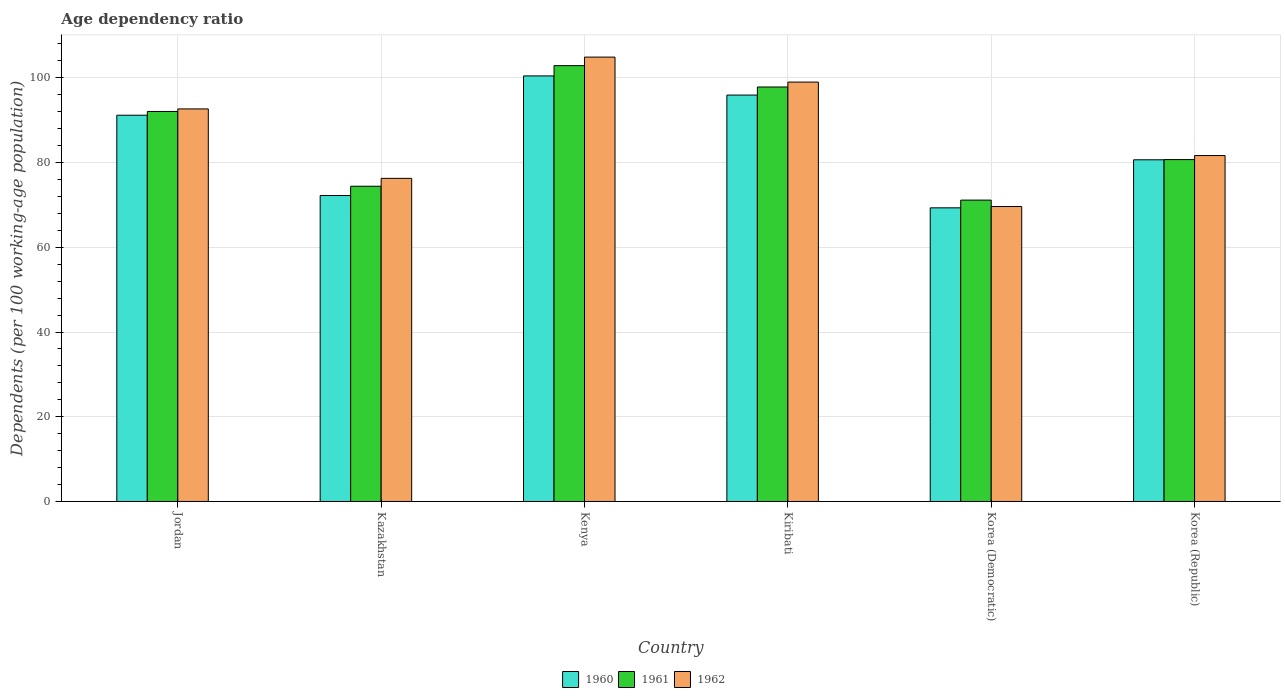How many different coloured bars are there?
Provide a succinct answer. 3. Are the number of bars per tick equal to the number of legend labels?
Your answer should be compact. Yes. How many bars are there on the 3rd tick from the left?
Your answer should be very brief. 3. How many bars are there on the 4th tick from the right?
Your response must be concise. 3. What is the label of the 2nd group of bars from the left?
Provide a short and direct response. Kazakhstan. What is the age dependency ratio in in 1961 in Korea (Republic)?
Offer a terse response. 80.71. Across all countries, what is the maximum age dependency ratio in in 1962?
Your response must be concise. 104.91. Across all countries, what is the minimum age dependency ratio in in 1960?
Your answer should be compact. 69.32. In which country was the age dependency ratio in in 1960 maximum?
Offer a very short reply. Kenya. In which country was the age dependency ratio in in 1962 minimum?
Ensure brevity in your answer.  Korea (Democratic). What is the total age dependency ratio in in 1962 in the graph?
Provide a short and direct response. 524.17. What is the difference between the age dependency ratio in in 1961 in Kiribati and that in Korea (Republic)?
Offer a very short reply. 17.14. What is the difference between the age dependency ratio in in 1960 in Kazakhstan and the age dependency ratio in in 1962 in Korea (Democratic)?
Give a very brief answer. 2.6. What is the average age dependency ratio in in 1962 per country?
Your response must be concise. 87.36. What is the difference between the age dependency ratio in of/in 1960 and age dependency ratio in of/in 1961 in Korea (Democratic)?
Make the answer very short. -1.83. What is the ratio of the age dependency ratio in in 1960 in Jordan to that in Kazakhstan?
Keep it short and to the point. 1.26. What is the difference between the highest and the second highest age dependency ratio in in 1962?
Keep it short and to the point. 5.9. What is the difference between the highest and the lowest age dependency ratio in in 1960?
Your response must be concise. 31.14. In how many countries, is the age dependency ratio in in 1961 greater than the average age dependency ratio in in 1961 taken over all countries?
Keep it short and to the point. 3. Is the sum of the age dependency ratio in in 1961 in Kenya and Kiribati greater than the maximum age dependency ratio in in 1962 across all countries?
Give a very brief answer. Yes. What does the 1st bar from the left in Kenya represents?
Offer a terse response. 1960. How many bars are there?
Make the answer very short. 18. What is the difference between two consecutive major ticks on the Y-axis?
Provide a succinct answer. 20. Are the values on the major ticks of Y-axis written in scientific E-notation?
Your response must be concise. No. Does the graph contain any zero values?
Ensure brevity in your answer.  No. Does the graph contain grids?
Give a very brief answer. Yes. What is the title of the graph?
Ensure brevity in your answer.  Age dependency ratio. What is the label or title of the Y-axis?
Keep it short and to the point. Dependents (per 100 working-age population). What is the Dependents (per 100 working-age population) in 1960 in Jordan?
Your answer should be very brief. 91.19. What is the Dependents (per 100 working-age population) in 1961 in Jordan?
Your response must be concise. 92.07. What is the Dependents (per 100 working-age population) of 1962 in Jordan?
Ensure brevity in your answer.  92.68. What is the Dependents (per 100 working-age population) in 1960 in Kazakhstan?
Provide a short and direct response. 72.23. What is the Dependents (per 100 working-age population) in 1961 in Kazakhstan?
Offer a terse response. 74.42. What is the Dependents (per 100 working-age population) of 1962 in Kazakhstan?
Provide a short and direct response. 76.28. What is the Dependents (per 100 working-age population) in 1960 in Kenya?
Your response must be concise. 100.46. What is the Dependents (per 100 working-age population) of 1961 in Kenya?
Your response must be concise. 102.89. What is the Dependents (per 100 working-age population) in 1962 in Kenya?
Offer a terse response. 104.91. What is the Dependents (per 100 working-age population) of 1960 in Kiribati?
Your answer should be compact. 95.94. What is the Dependents (per 100 working-age population) in 1961 in Kiribati?
Your answer should be compact. 97.85. What is the Dependents (per 100 working-age population) in 1962 in Kiribati?
Give a very brief answer. 99.01. What is the Dependents (per 100 working-age population) in 1960 in Korea (Democratic)?
Give a very brief answer. 69.32. What is the Dependents (per 100 working-age population) in 1961 in Korea (Democratic)?
Make the answer very short. 71.15. What is the Dependents (per 100 working-age population) in 1962 in Korea (Democratic)?
Your answer should be very brief. 69.63. What is the Dependents (per 100 working-age population) of 1960 in Korea (Republic)?
Your answer should be compact. 80.67. What is the Dependents (per 100 working-age population) in 1961 in Korea (Republic)?
Your response must be concise. 80.71. What is the Dependents (per 100 working-age population) of 1962 in Korea (Republic)?
Provide a short and direct response. 81.67. Across all countries, what is the maximum Dependents (per 100 working-age population) in 1960?
Keep it short and to the point. 100.46. Across all countries, what is the maximum Dependents (per 100 working-age population) of 1961?
Provide a short and direct response. 102.89. Across all countries, what is the maximum Dependents (per 100 working-age population) in 1962?
Provide a short and direct response. 104.91. Across all countries, what is the minimum Dependents (per 100 working-age population) of 1960?
Your answer should be compact. 69.32. Across all countries, what is the minimum Dependents (per 100 working-age population) in 1961?
Keep it short and to the point. 71.15. Across all countries, what is the minimum Dependents (per 100 working-age population) in 1962?
Provide a short and direct response. 69.63. What is the total Dependents (per 100 working-age population) of 1960 in the graph?
Your response must be concise. 509.81. What is the total Dependents (per 100 working-age population) of 1961 in the graph?
Ensure brevity in your answer.  519.1. What is the total Dependents (per 100 working-age population) in 1962 in the graph?
Give a very brief answer. 524.17. What is the difference between the Dependents (per 100 working-age population) in 1960 in Jordan and that in Kazakhstan?
Your response must be concise. 18.96. What is the difference between the Dependents (per 100 working-age population) of 1961 in Jordan and that in Kazakhstan?
Your answer should be very brief. 17.65. What is the difference between the Dependents (per 100 working-age population) in 1962 in Jordan and that in Kazakhstan?
Your answer should be compact. 16.39. What is the difference between the Dependents (per 100 working-age population) of 1960 in Jordan and that in Kenya?
Provide a short and direct response. -9.28. What is the difference between the Dependents (per 100 working-age population) of 1961 in Jordan and that in Kenya?
Your response must be concise. -10.82. What is the difference between the Dependents (per 100 working-age population) in 1962 in Jordan and that in Kenya?
Give a very brief answer. -12.23. What is the difference between the Dependents (per 100 working-age population) in 1960 in Jordan and that in Kiribati?
Provide a short and direct response. -4.76. What is the difference between the Dependents (per 100 working-age population) of 1961 in Jordan and that in Kiribati?
Ensure brevity in your answer.  -5.78. What is the difference between the Dependents (per 100 working-age population) of 1962 in Jordan and that in Kiribati?
Keep it short and to the point. -6.33. What is the difference between the Dependents (per 100 working-age population) of 1960 in Jordan and that in Korea (Democratic)?
Offer a very short reply. 21.86. What is the difference between the Dependents (per 100 working-age population) of 1961 in Jordan and that in Korea (Democratic)?
Provide a short and direct response. 20.93. What is the difference between the Dependents (per 100 working-age population) in 1962 in Jordan and that in Korea (Democratic)?
Keep it short and to the point. 23.04. What is the difference between the Dependents (per 100 working-age population) in 1960 in Jordan and that in Korea (Republic)?
Give a very brief answer. 10.52. What is the difference between the Dependents (per 100 working-age population) of 1961 in Jordan and that in Korea (Republic)?
Offer a terse response. 11.36. What is the difference between the Dependents (per 100 working-age population) of 1962 in Jordan and that in Korea (Republic)?
Provide a succinct answer. 11.01. What is the difference between the Dependents (per 100 working-age population) of 1960 in Kazakhstan and that in Kenya?
Give a very brief answer. -28.24. What is the difference between the Dependents (per 100 working-age population) of 1961 in Kazakhstan and that in Kenya?
Provide a short and direct response. -28.47. What is the difference between the Dependents (per 100 working-age population) of 1962 in Kazakhstan and that in Kenya?
Provide a short and direct response. -28.63. What is the difference between the Dependents (per 100 working-age population) of 1960 in Kazakhstan and that in Kiribati?
Provide a short and direct response. -23.71. What is the difference between the Dependents (per 100 working-age population) in 1961 in Kazakhstan and that in Kiribati?
Your response must be concise. -23.43. What is the difference between the Dependents (per 100 working-age population) of 1962 in Kazakhstan and that in Kiribati?
Offer a very short reply. -22.73. What is the difference between the Dependents (per 100 working-age population) of 1960 in Kazakhstan and that in Korea (Democratic)?
Your response must be concise. 2.9. What is the difference between the Dependents (per 100 working-age population) of 1961 in Kazakhstan and that in Korea (Democratic)?
Your answer should be compact. 3.27. What is the difference between the Dependents (per 100 working-age population) in 1962 in Kazakhstan and that in Korea (Democratic)?
Ensure brevity in your answer.  6.65. What is the difference between the Dependents (per 100 working-age population) of 1960 in Kazakhstan and that in Korea (Republic)?
Your answer should be very brief. -8.44. What is the difference between the Dependents (per 100 working-age population) of 1961 in Kazakhstan and that in Korea (Republic)?
Offer a terse response. -6.29. What is the difference between the Dependents (per 100 working-age population) in 1962 in Kazakhstan and that in Korea (Republic)?
Your answer should be compact. -5.38. What is the difference between the Dependents (per 100 working-age population) of 1960 in Kenya and that in Kiribati?
Ensure brevity in your answer.  4.52. What is the difference between the Dependents (per 100 working-age population) in 1961 in Kenya and that in Kiribati?
Ensure brevity in your answer.  5.04. What is the difference between the Dependents (per 100 working-age population) in 1962 in Kenya and that in Kiribati?
Your answer should be compact. 5.9. What is the difference between the Dependents (per 100 working-age population) of 1960 in Kenya and that in Korea (Democratic)?
Your answer should be very brief. 31.14. What is the difference between the Dependents (per 100 working-age population) of 1961 in Kenya and that in Korea (Democratic)?
Offer a terse response. 31.74. What is the difference between the Dependents (per 100 working-age population) in 1962 in Kenya and that in Korea (Democratic)?
Your answer should be very brief. 35.28. What is the difference between the Dependents (per 100 working-age population) in 1960 in Kenya and that in Korea (Republic)?
Provide a succinct answer. 19.8. What is the difference between the Dependents (per 100 working-age population) in 1961 in Kenya and that in Korea (Republic)?
Make the answer very short. 22.18. What is the difference between the Dependents (per 100 working-age population) of 1962 in Kenya and that in Korea (Republic)?
Give a very brief answer. 23.24. What is the difference between the Dependents (per 100 working-age population) of 1960 in Kiribati and that in Korea (Democratic)?
Your response must be concise. 26.62. What is the difference between the Dependents (per 100 working-age population) of 1961 in Kiribati and that in Korea (Democratic)?
Keep it short and to the point. 26.7. What is the difference between the Dependents (per 100 working-age population) of 1962 in Kiribati and that in Korea (Democratic)?
Your answer should be very brief. 29.38. What is the difference between the Dependents (per 100 working-age population) in 1960 in Kiribati and that in Korea (Republic)?
Give a very brief answer. 15.28. What is the difference between the Dependents (per 100 working-age population) in 1961 in Kiribati and that in Korea (Republic)?
Make the answer very short. 17.14. What is the difference between the Dependents (per 100 working-age population) in 1962 in Kiribati and that in Korea (Republic)?
Offer a terse response. 17.34. What is the difference between the Dependents (per 100 working-age population) of 1960 in Korea (Democratic) and that in Korea (Republic)?
Give a very brief answer. -11.34. What is the difference between the Dependents (per 100 working-age population) in 1961 in Korea (Democratic) and that in Korea (Republic)?
Give a very brief answer. -9.56. What is the difference between the Dependents (per 100 working-age population) of 1962 in Korea (Democratic) and that in Korea (Republic)?
Your response must be concise. -12.03. What is the difference between the Dependents (per 100 working-age population) in 1960 in Jordan and the Dependents (per 100 working-age population) in 1961 in Kazakhstan?
Make the answer very short. 16.77. What is the difference between the Dependents (per 100 working-age population) of 1960 in Jordan and the Dependents (per 100 working-age population) of 1962 in Kazakhstan?
Your answer should be compact. 14.91. What is the difference between the Dependents (per 100 working-age population) in 1961 in Jordan and the Dependents (per 100 working-age population) in 1962 in Kazakhstan?
Ensure brevity in your answer.  15.79. What is the difference between the Dependents (per 100 working-age population) of 1960 in Jordan and the Dependents (per 100 working-age population) of 1961 in Kenya?
Keep it short and to the point. -11.7. What is the difference between the Dependents (per 100 working-age population) in 1960 in Jordan and the Dependents (per 100 working-age population) in 1962 in Kenya?
Offer a very short reply. -13.72. What is the difference between the Dependents (per 100 working-age population) of 1961 in Jordan and the Dependents (per 100 working-age population) of 1962 in Kenya?
Provide a short and direct response. -12.83. What is the difference between the Dependents (per 100 working-age population) in 1960 in Jordan and the Dependents (per 100 working-age population) in 1961 in Kiribati?
Ensure brevity in your answer.  -6.66. What is the difference between the Dependents (per 100 working-age population) of 1960 in Jordan and the Dependents (per 100 working-age population) of 1962 in Kiribati?
Make the answer very short. -7.82. What is the difference between the Dependents (per 100 working-age population) of 1961 in Jordan and the Dependents (per 100 working-age population) of 1962 in Kiribati?
Offer a terse response. -6.93. What is the difference between the Dependents (per 100 working-age population) of 1960 in Jordan and the Dependents (per 100 working-age population) of 1961 in Korea (Democratic)?
Your response must be concise. 20.04. What is the difference between the Dependents (per 100 working-age population) in 1960 in Jordan and the Dependents (per 100 working-age population) in 1962 in Korea (Democratic)?
Your answer should be very brief. 21.56. What is the difference between the Dependents (per 100 working-age population) in 1961 in Jordan and the Dependents (per 100 working-age population) in 1962 in Korea (Democratic)?
Give a very brief answer. 22.44. What is the difference between the Dependents (per 100 working-age population) of 1960 in Jordan and the Dependents (per 100 working-age population) of 1961 in Korea (Republic)?
Keep it short and to the point. 10.47. What is the difference between the Dependents (per 100 working-age population) of 1960 in Jordan and the Dependents (per 100 working-age population) of 1962 in Korea (Republic)?
Provide a short and direct response. 9.52. What is the difference between the Dependents (per 100 working-age population) of 1961 in Jordan and the Dependents (per 100 working-age population) of 1962 in Korea (Republic)?
Make the answer very short. 10.41. What is the difference between the Dependents (per 100 working-age population) of 1960 in Kazakhstan and the Dependents (per 100 working-age population) of 1961 in Kenya?
Provide a succinct answer. -30.66. What is the difference between the Dependents (per 100 working-age population) of 1960 in Kazakhstan and the Dependents (per 100 working-age population) of 1962 in Kenya?
Give a very brief answer. -32.68. What is the difference between the Dependents (per 100 working-age population) in 1961 in Kazakhstan and the Dependents (per 100 working-age population) in 1962 in Kenya?
Ensure brevity in your answer.  -30.49. What is the difference between the Dependents (per 100 working-age population) in 1960 in Kazakhstan and the Dependents (per 100 working-age population) in 1961 in Kiribati?
Keep it short and to the point. -25.62. What is the difference between the Dependents (per 100 working-age population) in 1960 in Kazakhstan and the Dependents (per 100 working-age population) in 1962 in Kiribati?
Provide a succinct answer. -26.78. What is the difference between the Dependents (per 100 working-age population) of 1961 in Kazakhstan and the Dependents (per 100 working-age population) of 1962 in Kiribati?
Your response must be concise. -24.59. What is the difference between the Dependents (per 100 working-age population) of 1960 in Kazakhstan and the Dependents (per 100 working-age population) of 1961 in Korea (Democratic)?
Ensure brevity in your answer.  1.08. What is the difference between the Dependents (per 100 working-age population) in 1960 in Kazakhstan and the Dependents (per 100 working-age population) in 1962 in Korea (Democratic)?
Make the answer very short. 2.6. What is the difference between the Dependents (per 100 working-age population) of 1961 in Kazakhstan and the Dependents (per 100 working-age population) of 1962 in Korea (Democratic)?
Keep it short and to the point. 4.79. What is the difference between the Dependents (per 100 working-age population) in 1960 in Kazakhstan and the Dependents (per 100 working-age population) in 1961 in Korea (Republic)?
Keep it short and to the point. -8.48. What is the difference between the Dependents (per 100 working-age population) of 1960 in Kazakhstan and the Dependents (per 100 working-age population) of 1962 in Korea (Republic)?
Provide a short and direct response. -9.44. What is the difference between the Dependents (per 100 working-age population) of 1961 in Kazakhstan and the Dependents (per 100 working-age population) of 1962 in Korea (Republic)?
Make the answer very short. -7.25. What is the difference between the Dependents (per 100 working-age population) of 1960 in Kenya and the Dependents (per 100 working-age population) of 1961 in Kiribati?
Make the answer very short. 2.61. What is the difference between the Dependents (per 100 working-age population) in 1960 in Kenya and the Dependents (per 100 working-age population) in 1962 in Kiribati?
Your response must be concise. 1.46. What is the difference between the Dependents (per 100 working-age population) in 1961 in Kenya and the Dependents (per 100 working-age population) in 1962 in Kiribati?
Offer a very short reply. 3.88. What is the difference between the Dependents (per 100 working-age population) of 1960 in Kenya and the Dependents (per 100 working-age population) of 1961 in Korea (Democratic)?
Your answer should be compact. 29.32. What is the difference between the Dependents (per 100 working-age population) in 1960 in Kenya and the Dependents (per 100 working-age population) in 1962 in Korea (Democratic)?
Ensure brevity in your answer.  30.83. What is the difference between the Dependents (per 100 working-age population) in 1961 in Kenya and the Dependents (per 100 working-age population) in 1962 in Korea (Democratic)?
Provide a short and direct response. 33.26. What is the difference between the Dependents (per 100 working-age population) of 1960 in Kenya and the Dependents (per 100 working-age population) of 1961 in Korea (Republic)?
Your answer should be very brief. 19.75. What is the difference between the Dependents (per 100 working-age population) of 1960 in Kenya and the Dependents (per 100 working-age population) of 1962 in Korea (Republic)?
Make the answer very short. 18.8. What is the difference between the Dependents (per 100 working-age population) of 1961 in Kenya and the Dependents (per 100 working-age population) of 1962 in Korea (Republic)?
Offer a very short reply. 21.22. What is the difference between the Dependents (per 100 working-age population) of 1960 in Kiribati and the Dependents (per 100 working-age population) of 1961 in Korea (Democratic)?
Your answer should be compact. 24.79. What is the difference between the Dependents (per 100 working-age population) of 1960 in Kiribati and the Dependents (per 100 working-age population) of 1962 in Korea (Democratic)?
Offer a very short reply. 26.31. What is the difference between the Dependents (per 100 working-age population) of 1961 in Kiribati and the Dependents (per 100 working-age population) of 1962 in Korea (Democratic)?
Offer a terse response. 28.22. What is the difference between the Dependents (per 100 working-age population) in 1960 in Kiribati and the Dependents (per 100 working-age population) in 1961 in Korea (Republic)?
Provide a succinct answer. 15.23. What is the difference between the Dependents (per 100 working-age population) in 1960 in Kiribati and the Dependents (per 100 working-age population) in 1962 in Korea (Republic)?
Make the answer very short. 14.28. What is the difference between the Dependents (per 100 working-age population) in 1961 in Kiribati and the Dependents (per 100 working-age population) in 1962 in Korea (Republic)?
Offer a terse response. 16.19. What is the difference between the Dependents (per 100 working-age population) of 1960 in Korea (Democratic) and the Dependents (per 100 working-age population) of 1961 in Korea (Republic)?
Give a very brief answer. -11.39. What is the difference between the Dependents (per 100 working-age population) of 1960 in Korea (Democratic) and the Dependents (per 100 working-age population) of 1962 in Korea (Republic)?
Keep it short and to the point. -12.34. What is the difference between the Dependents (per 100 working-age population) of 1961 in Korea (Democratic) and the Dependents (per 100 working-age population) of 1962 in Korea (Republic)?
Your answer should be very brief. -10.52. What is the average Dependents (per 100 working-age population) in 1960 per country?
Make the answer very short. 84.97. What is the average Dependents (per 100 working-age population) of 1961 per country?
Your response must be concise. 86.52. What is the average Dependents (per 100 working-age population) in 1962 per country?
Ensure brevity in your answer.  87.36. What is the difference between the Dependents (per 100 working-age population) of 1960 and Dependents (per 100 working-age population) of 1961 in Jordan?
Offer a terse response. -0.89. What is the difference between the Dependents (per 100 working-age population) in 1960 and Dependents (per 100 working-age population) in 1962 in Jordan?
Make the answer very short. -1.49. What is the difference between the Dependents (per 100 working-age population) in 1961 and Dependents (per 100 working-age population) in 1962 in Jordan?
Your answer should be very brief. -0.6. What is the difference between the Dependents (per 100 working-age population) in 1960 and Dependents (per 100 working-age population) in 1961 in Kazakhstan?
Ensure brevity in your answer.  -2.19. What is the difference between the Dependents (per 100 working-age population) of 1960 and Dependents (per 100 working-age population) of 1962 in Kazakhstan?
Provide a succinct answer. -4.05. What is the difference between the Dependents (per 100 working-age population) in 1961 and Dependents (per 100 working-age population) in 1962 in Kazakhstan?
Provide a succinct answer. -1.86. What is the difference between the Dependents (per 100 working-age population) in 1960 and Dependents (per 100 working-age population) in 1961 in Kenya?
Provide a succinct answer. -2.42. What is the difference between the Dependents (per 100 working-age population) in 1960 and Dependents (per 100 working-age population) in 1962 in Kenya?
Your answer should be very brief. -4.44. What is the difference between the Dependents (per 100 working-age population) in 1961 and Dependents (per 100 working-age population) in 1962 in Kenya?
Keep it short and to the point. -2.02. What is the difference between the Dependents (per 100 working-age population) of 1960 and Dependents (per 100 working-age population) of 1961 in Kiribati?
Your response must be concise. -1.91. What is the difference between the Dependents (per 100 working-age population) in 1960 and Dependents (per 100 working-age population) in 1962 in Kiribati?
Ensure brevity in your answer.  -3.07. What is the difference between the Dependents (per 100 working-age population) of 1961 and Dependents (per 100 working-age population) of 1962 in Kiribati?
Your response must be concise. -1.16. What is the difference between the Dependents (per 100 working-age population) in 1960 and Dependents (per 100 working-age population) in 1961 in Korea (Democratic)?
Ensure brevity in your answer.  -1.83. What is the difference between the Dependents (per 100 working-age population) in 1960 and Dependents (per 100 working-age population) in 1962 in Korea (Democratic)?
Offer a terse response. -0.31. What is the difference between the Dependents (per 100 working-age population) in 1961 and Dependents (per 100 working-age population) in 1962 in Korea (Democratic)?
Ensure brevity in your answer.  1.52. What is the difference between the Dependents (per 100 working-age population) in 1960 and Dependents (per 100 working-age population) in 1961 in Korea (Republic)?
Make the answer very short. -0.05. What is the difference between the Dependents (per 100 working-age population) in 1960 and Dependents (per 100 working-age population) in 1962 in Korea (Republic)?
Give a very brief answer. -1. What is the difference between the Dependents (per 100 working-age population) in 1961 and Dependents (per 100 working-age population) in 1962 in Korea (Republic)?
Your answer should be compact. -0.95. What is the ratio of the Dependents (per 100 working-age population) in 1960 in Jordan to that in Kazakhstan?
Offer a terse response. 1.26. What is the ratio of the Dependents (per 100 working-age population) in 1961 in Jordan to that in Kazakhstan?
Ensure brevity in your answer.  1.24. What is the ratio of the Dependents (per 100 working-age population) in 1962 in Jordan to that in Kazakhstan?
Ensure brevity in your answer.  1.21. What is the ratio of the Dependents (per 100 working-age population) in 1960 in Jordan to that in Kenya?
Your response must be concise. 0.91. What is the ratio of the Dependents (per 100 working-age population) in 1961 in Jordan to that in Kenya?
Give a very brief answer. 0.89. What is the ratio of the Dependents (per 100 working-age population) in 1962 in Jordan to that in Kenya?
Ensure brevity in your answer.  0.88. What is the ratio of the Dependents (per 100 working-age population) in 1960 in Jordan to that in Kiribati?
Keep it short and to the point. 0.95. What is the ratio of the Dependents (per 100 working-age population) in 1961 in Jordan to that in Kiribati?
Ensure brevity in your answer.  0.94. What is the ratio of the Dependents (per 100 working-age population) of 1962 in Jordan to that in Kiribati?
Your response must be concise. 0.94. What is the ratio of the Dependents (per 100 working-age population) in 1960 in Jordan to that in Korea (Democratic)?
Offer a terse response. 1.32. What is the ratio of the Dependents (per 100 working-age population) in 1961 in Jordan to that in Korea (Democratic)?
Keep it short and to the point. 1.29. What is the ratio of the Dependents (per 100 working-age population) of 1962 in Jordan to that in Korea (Democratic)?
Ensure brevity in your answer.  1.33. What is the ratio of the Dependents (per 100 working-age population) of 1960 in Jordan to that in Korea (Republic)?
Offer a terse response. 1.13. What is the ratio of the Dependents (per 100 working-age population) in 1961 in Jordan to that in Korea (Republic)?
Provide a short and direct response. 1.14. What is the ratio of the Dependents (per 100 working-age population) of 1962 in Jordan to that in Korea (Republic)?
Your answer should be compact. 1.13. What is the ratio of the Dependents (per 100 working-age population) in 1960 in Kazakhstan to that in Kenya?
Give a very brief answer. 0.72. What is the ratio of the Dependents (per 100 working-age population) of 1961 in Kazakhstan to that in Kenya?
Your response must be concise. 0.72. What is the ratio of the Dependents (per 100 working-age population) in 1962 in Kazakhstan to that in Kenya?
Offer a terse response. 0.73. What is the ratio of the Dependents (per 100 working-age population) in 1960 in Kazakhstan to that in Kiribati?
Your answer should be very brief. 0.75. What is the ratio of the Dependents (per 100 working-age population) in 1961 in Kazakhstan to that in Kiribati?
Your answer should be very brief. 0.76. What is the ratio of the Dependents (per 100 working-age population) in 1962 in Kazakhstan to that in Kiribati?
Ensure brevity in your answer.  0.77. What is the ratio of the Dependents (per 100 working-age population) of 1960 in Kazakhstan to that in Korea (Democratic)?
Your answer should be compact. 1.04. What is the ratio of the Dependents (per 100 working-age population) of 1961 in Kazakhstan to that in Korea (Democratic)?
Provide a succinct answer. 1.05. What is the ratio of the Dependents (per 100 working-age population) in 1962 in Kazakhstan to that in Korea (Democratic)?
Your response must be concise. 1.1. What is the ratio of the Dependents (per 100 working-age population) of 1960 in Kazakhstan to that in Korea (Republic)?
Make the answer very short. 0.9. What is the ratio of the Dependents (per 100 working-age population) in 1961 in Kazakhstan to that in Korea (Republic)?
Provide a succinct answer. 0.92. What is the ratio of the Dependents (per 100 working-age population) of 1962 in Kazakhstan to that in Korea (Republic)?
Your answer should be compact. 0.93. What is the ratio of the Dependents (per 100 working-age population) in 1960 in Kenya to that in Kiribati?
Your answer should be very brief. 1.05. What is the ratio of the Dependents (per 100 working-age population) in 1961 in Kenya to that in Kiribati?
Your response must be concise. 1.05. What is the ratio of the Dependents (per 100 working-age population) in 1962 in Kenya to that in Kiribati?
Ensure brevity in your answer.  1.06. What is the ratio of the Dependents (per 100 working-age population) of 1960 in Kenya to that in Korea (Democratic)?
Ensure brevity in your answer.  1.45. What is the ratio of the Dependents (per 100 working-age population) of 1961 in Kenya to that in Korea (Democratic)?
Offer a terse response. 1.45. What is the ratio of the Dependents (per 100 working-age population) in 1962 in Kenya to that in Korea (Democratic)?
Keep it short and to the point. 1.51. What is the ratio of the Dependents (per 100 working-age population) in 1960 in Kenya to that in Korea (Republic)?
Your answer should be very brief. 1.25. What is the ratio of the Dependents (per 100 working-age population) in 1961 in Kenya to that in Korea (Republic)?
Your answer should be very brief. 1.27. What is the ratio of the Dependents (per 100 working-age population) in 1962 in Kenya to that in Korea (Republic)?
Your response must be concise. 1.28. What is the ratio of the Dependents (per 100 working-age population) in 1960 in Kiribati to that in Korea (Democratic)?
Provide a succinct answer. 1.38. What is the ratio of the Dependents (per 100 working-age population) in 1961 in Kiribati to that in Korea (Democratic)?
Your answer should be compact. 1.38. What is the ratio of the Dependents (per 100 working-age population) of 1962 in Kiribati to that in Korea (Democratic)?
Provide a short and direct response. 1.42. What is the ratio of the Dependents (per 100 working-age population) of 1960 in Kiribati to that in Korea (Republic)?
Keep it short and to the point. 1.19. What is the ratio of the Dependents (per 100 working-age population) of 1961 in Kiribati to that in Korea (Republic)?
Keep it short and to the point. 1.21. What is the ratio of the Dependents (per 100 working-age population) in 1962 in Kiribati to that in Korea (Republic)?
Provide a short and direct response. 1.21. What is the ratio of the Dependents (per 100 working-age population) in 1960 in Korea (Democratic) to that in Korea (Republic)?
Offer a terse response. 0.86. What is the ratio of the Dependents (per 100 working-age population) in 1961 in Korea (Democratic) to that in Korea (Republic)?
Ensure brevity in your answer.  0.88. What is the ratio of the Dependents (per 100 working-age population) in 1962 in Korea (Democratic) to that in Korea (Republic)?
Offer a terse response. 0.85. What is the difference between the highest and the second highest Dependents (per 100 working-age population) of 1960?
Ensure brevity in your answer.  4.52. What is the difference between the highest and the second highest Dependents (per 100 working-age population) of 1961?
Offer a terse response. 5.04. What is the difference between the highest and the second highest Dependents (per 100 working-age population) of 1962?
Make the answer very short. 5.9. What is the difference between the highest and the lowest Dependents (per 100 working-age population) of 1960?
Offer a very short reply. 31.14. What is the difference between the highest and the lowest Dependents (per 100 working-age population) of 1961?
Provide a succinct answer. 31.74. What is the difference between the highest and the lowest Dependents (per 100 working-age population) in 1962?
Your answer should be compact. 35.28. 